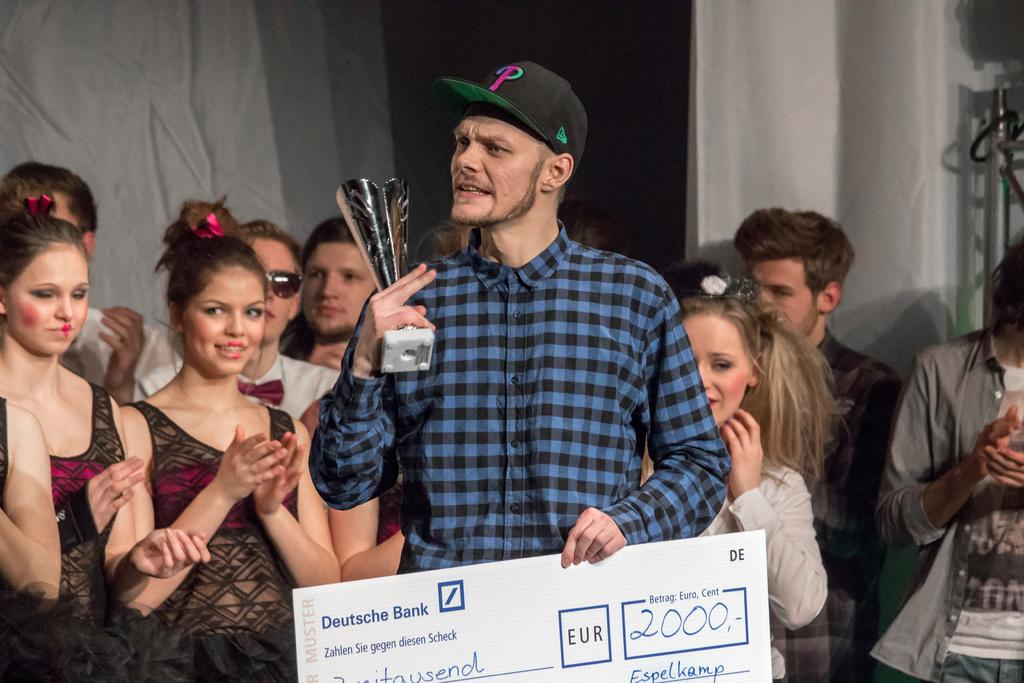Who is the main subject in the image? There is a person in the image. What is the person wearing? The person is wearing a blue dress. What is the person holding in the image? The person is holding an award. What else can be seen in the image? There is a check in the image. Are there any other people in the image? Yes, there are a group of persons standing in the background of the image. What type of magic trick is the person performing in the image? There is no indication of a magic trick being performed in the image. 